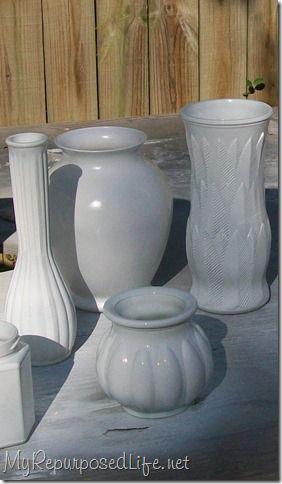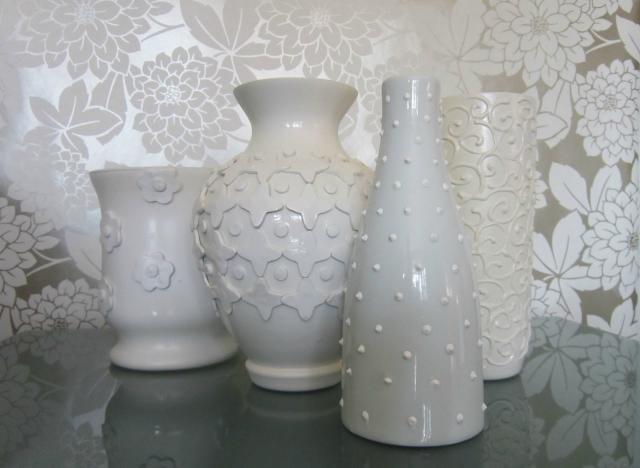The first image is the image on the left, the second image is the image on the right. Analyze the images presented: Is the assertion "In one image, a display of milk glass shows a squat pumpkin-shaped piece in front of one shaped like an urn." valid? Answer yes or no. Yes. 